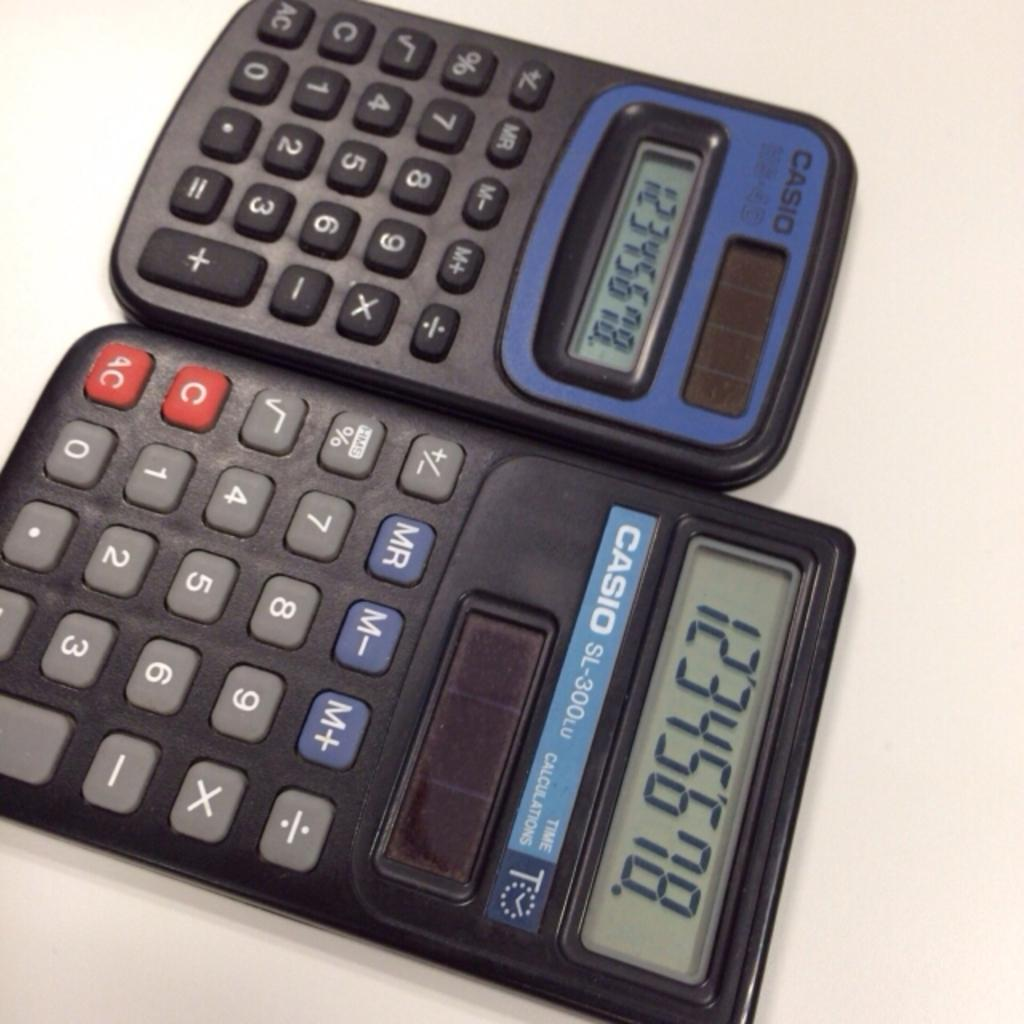Provide a one-sentence caption for the provided image. two calculators next to one another by the brand 'casio'. 